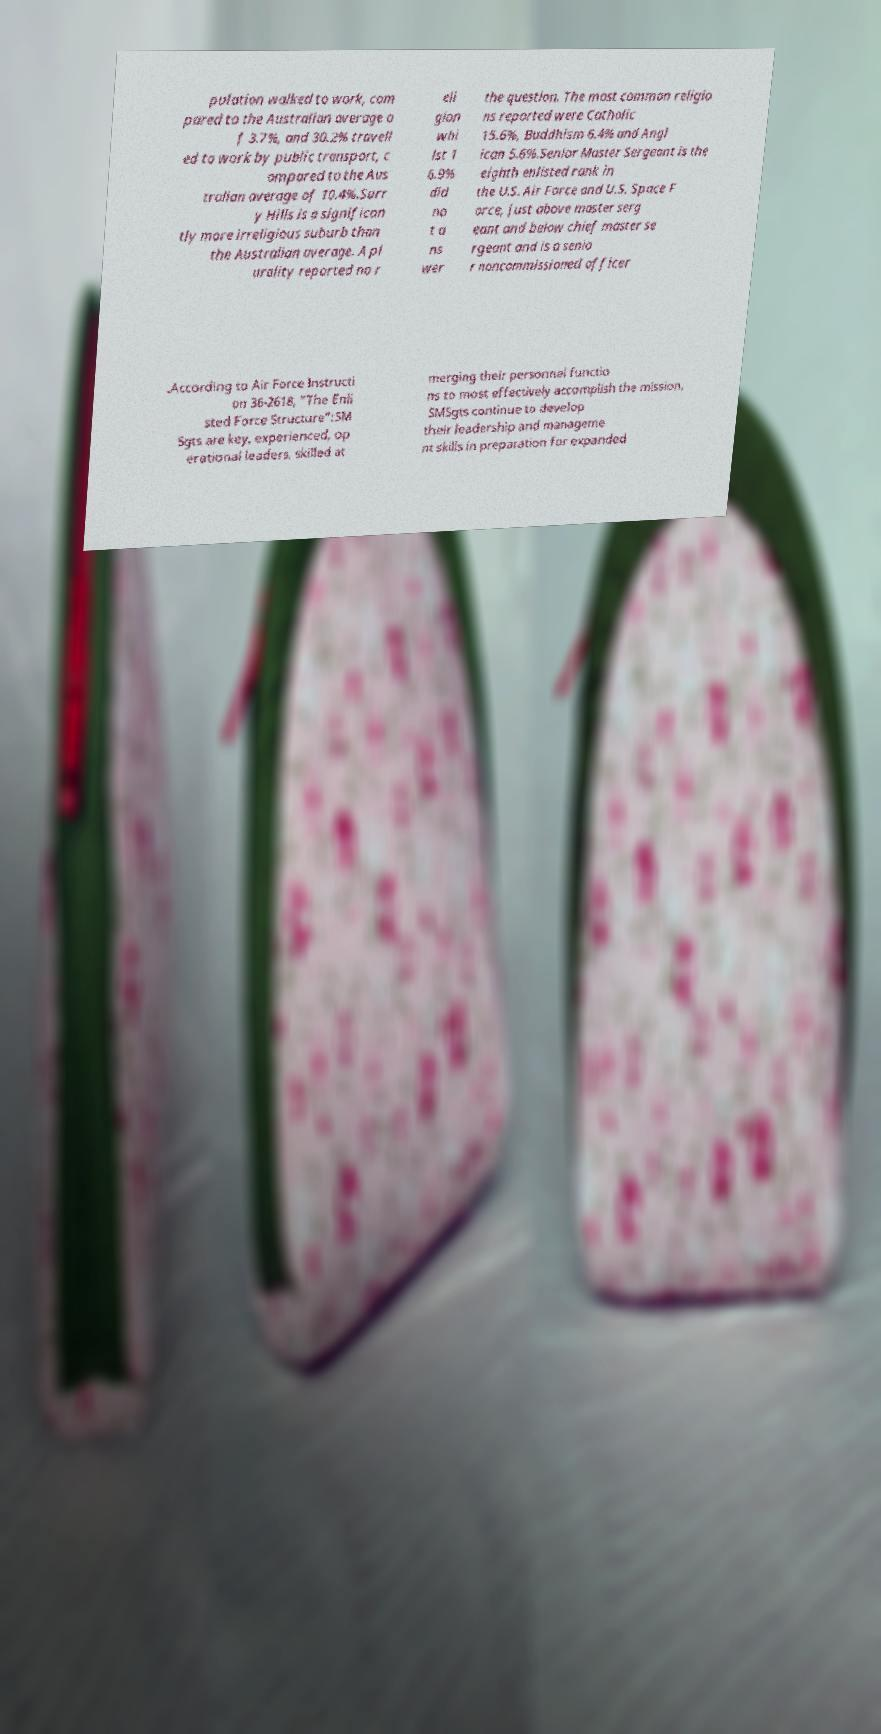For documentation purposes, I need the text within this image transcribed. Could you provide that? pulation walked to work, com pared to the Australian average o f 3.7%, and 30.2% travell ed to work by public transport, c ompared to the Aus tralian average of 10.4%.Surr y Hills is a significan tly more irreligious suburb than the Australian average. A pl urality reported no r eli gion whi lst 1 6.9% did no t a ns wer the question. The most common religio ns reported were Catholic 15.6%, Buddhism 6.4% and Angl ican 5.6%.Senior Master Sergeant is the eighth enlisted rank in the U.S. Air Force and U.S. Space F orce, just above master serg eant and below chief master se rgeant and is a senio r noncommissioned officer .According to Air Force Instructi on 36-2618, "The Enli sted Force Structure":SM Sgts are key, experienced, op erational leaders, skilled at merging their personnel functio ns to most effectively accomplish the mission. SMSgts continue to develop their leadership and manageme nt skills in preparation for expanded 